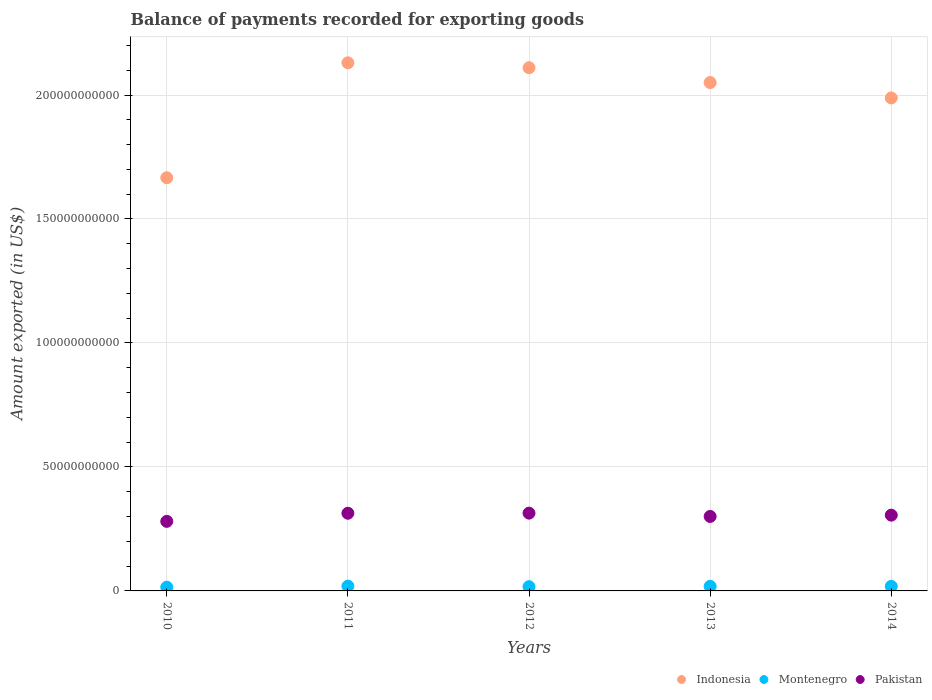What is the amount exported in Indonesia in 2011?
Your answer should be compact. 2.13e+11. Across all years, what is the maximum amount exported in Pakistan?
Your answer should be compact. 3.14e+1. Across all years, what is the minimum amount exported in Montenegro?
Ensure brevity in your answer.  1.50e+09. What is the total amount exported in Pakistan in the graph?
Keep it short and to the point. 1.51e+11. What is the difference between the amount exported in Indonesia in 2012 and that in 2013?
Offer a terse response. 5.97e+09. What is the difference between the amount exported in Indonesia in 2014 and the amount exported in Montenegro in 2012?
Your response must be concise. 1.97e+11. What is the average amount exported in Montenegro per year?
Provide a short and direct response. 1.77e+09. In the year 2013, what is the difference between the amount exported in Montenegro and amount exported in Indonesia?
Keep it short and to the point. -2.03e+11. What is the ratio of the amount exported in Indonesia in 2011 to that in 2013?
Make the answer very short. 1.04. Is the amount exported in Indonesia in 2010 less than that in 2013?
Ensure brevity in your answer.  Yes. What is the difference between the highest and the second highest amount exported in Pakistan?
Keep it short and to the point. 4.27e+07. What is the difference between the highest and the lowest amount exported in Pakistan?
Your answer should be very brief. 3.32e+09. Is it the case that in every year, the sum of the amount exported in Montenegro and amount exported in Pakistan  is greater than the amount exported in Indonesia?
Your answer should be very brief. No. Does the amount exported in Indonesia monotonically increase over the years?
Provide a succinct answer. No. How many dotlines are there?
Offer a terse response. 3. How many years are there in the graph?
Offer a terse response. 5. What is the difference between two consecutive major ticks on the Y-axis?
Give a very brief answer. 5.00e+1. Are the values on the major ticks of Y-axis written in scientific E-notation?
Offer a terse response. No. Does the graph contain any zero values?
Offer a terse response. No. Does the graph contain grids?
Offer a very short reply. Yes. How many legend labels are there?
Give a very brief answer. 3. How are the legend labels stacked?
Your response must be concise. Horizontal. What is the title of the graph?
Your answer should be very brief. Balance of payments recorded for exporting goods. Does "Somalia" appear as one of the legend labels in the graph?
Keep it short and to the point. No. What is the label or title of the Y-axis?
Offer a very short reply. Amount exported (in US$). What is the Amount exported (in US$) in Indonesia in 2010?
Keep it short and to the point. 1.67e+11. What is the Amount exported (in US$) of Montenegro in 2010?
Provide a short and direct response. 1.50e+09. What is the Amount exported (in US$) of Pakistan in 2010?
Your answer should be very brief. 2.81e+1. What is the Amount exported (in US$) in Indonesia in 2011?
Make the answer very short. 2.13e+11. What is the Amount exported (in US$) of Montenegro in 2011?
Offer a very short reply. 1.93e+09. What is the Amount exported (in US$) of Pakistan in 2011?
Your response must be concise. 3.13e+1. What is the Amount exported (in US$) of Indonesia in 2012?
Provide a short and direct response. 2.11e+11. What is the Amount exported (in US$) in Montenegro in 2012?
Keep it short and to the point. 1.71e+09. What is the Amount exported (in US$) of Pakistan in 2012?
Ensure brevity in your answer.  3.14e+1. What is the Amount exported (in US$) of Indonesia in 2013?
Offer a very short reply. 2.05e+11. What is the Amount exported (in US$) of Montenegro in 2013?
Offer a terse response. 1.84e+09. What is the Amount exported (in US$) of Pakistan in 2013?
Provide a short and direct response. 3.00e+1. What is the Amount exported (in US$) of Indonesia in 2014?
Ensure brevity in your answer.  1.99e+11. What is the Amount exported (in US$) of Montenegro in 2014?
Give a very brief answer. 1.84e+09. What is the Amount exported (in US$) in Pakistan in 2014?
Ensure brevity in your answer.  3.06e+1. Across all years, what is the maximum Amount exported (in US$) in Indonesia?
Make the answer very short. 2.13e+11. Across all years, what is the maximum Amount exported (in US$) of Montenegro?
Keep it short and to the point. 1.93e+09. Across all years, what is the maximum Amount exported (in US$) of Pakistan?
Your answer should be compact. 3.14e+1. Across all years, what is the minimum Amount exported (in US$) in Indonesia?
Your answer should be very brief. 1.67e+11. Across all years, what is the minimum Amount exported (in US$) in Montenegro?
Make the answer very short. 1.50e+09. Across all years, what is the minimum Amount exported (in US$) in Pakistan?
Your answer should be compact. 2.81e+1. What is the total Amount exported (in US$) in Indonesia in the graph?
Your answer should be very brief. 9.94e+11. What is the total Amount exported (in US$) in Montenegro in the graph?
Offer a terse response. 8.83e+09. What is the total Amount exported (in US$) in Pakistan in the graph?
Offer a terse response. 1.51e+11. What is the difference between the Amount exported (in US$) in Indonesia in 2010 and that in 2011?
Offer a terse response. -4.64e+1. What is the difference between the Amount exported (in US$) of Montenegro in 2010 and that in 2011?
Your answer should be very brief. -4.27e+08. What is the difference between the Amount exported (in US$) in Pakistan in 2010 and that in 2011?
Your answer should be very brief. -3.27e+09. What is the difference between the Amount exported (in US$) of Indonesia in 2010 and that in 2012?
Offer a very short reply. -4.44e+1. What is the difference between the Amount exported (in US$) of Montenegro in 2010 and that in 2012?
Your answer should be very brief. -2.07e+08. What is the difference between the Amount exported (in US$) of Pakistan in 2010 and that in 2012?
Offer a terse response. -3.32e+09. What is the difference between the Amount exported (in US$) in Indonesia in 2010 and that in 2013?
Your response must be concise. -3.84e+1. What is the difference between the Amount exported (in US$) of Montenegro in 2010 and that in 2013?
Offer a terse response. -3.40e+08. What is the difference between the Amount exported (in US$) in Pakistan in 2010 and that in 2013?
Make the answer very short. -1.98e+09. What is the difference between the Amount exported (in US$) in Indonesia in 2010 and that in 2014?
Your response must be concise. -3.22e+1. What is the difference between the Amount exported (in US$) in Montenegro in 2010 and that in 2014?
Give a very brief answer. -3.39e+08. What is the difference between the Amount exported (in US$) of Pakistan in 2010 and that in 2014?
Your answer should be compact. -2.50e+09. What is the difference between the Amount exported (in US$) in Indonesia in 2011 and that in 2012?
Ensure brevity in your answer.  1.99e+09. What is the difference between the Amount exported (in US$) in Montenegro in 2011 and that in 2012?
Provide a succinct answer. 2.20e+08. What is the difference between the Amount exported (in US$) of Pakistan in 2011 and that in 2012?
Ensure brevity in your answer.  -4.27e+07. What is the difference between the Amount exported (in US$) of Indonesia in 2011 and that in 2013?
Provide a short and direct response. 7.96e+09. What is the difference between the Amount exported (in US$) of Montenegro in 2011 and that in 2013?
Your answer should be very brief. 8.72e+07. What is the difference between the Amount exported (in US$) in Pakistan in 2011 and that in 2013?
Offer a terse response. 1.29e+09. What is the difference between the Amount exported (in US$) in Indonesia in 2011 and that in 2014?
Ensure brevity in your answer.  1.42e+1. What is the difference between the Amount exported (in US$) of Montenegro in 2011 and that in 2014?
Offer a very short reply. 8.82e+07. What is the difference between the Amount exported (in US$) in Pakistan in 2011 and that in 2014?
Your response must be concise. 7.67e+08. What is the difference between the Amount exported (in US$) in Indonesia in 2012 and that in 2013?
Make the answer very short. 5.97e+09. What is the difference between the Amount exported (in US$) in Montenegro in 2012 and that in 2013?
Your answer should be compact. -1.33e+08. What is the difference between the Amount exported (in US$) in Pakistan in 2012 and that in 2013?
Your response must be concise. 1.34e+09. What is the difference between the Amount exported (in US$) of Indonesia in 2012 and that in 2014?
Keep it short and to the point. 1.22e+1. What is the difference between the Amount exported (in US$) of Montenegro in 2012 and that in 2014?
Your response must be concise. -1.32e+08. What is the difference between the Amount exported (in US$) in Pakistan in 2012 and that in 2014?
Offer a very short reply. 8.10e+08. What is the difference between the Amount exported (in US$) in Indonesia in 2013 and that in 2014?
Offer a terse response. 6.21e+09. What is the difference between the Amount exported (in US$) of Montenegro in 2013 and that in 2014?
Make the answer very short. 9.82e+05. What is the difference between the Amount exported (in US$) in Pakistan in 2013 and that in 2014?
Provide a succinct answer. -5.26e+08. What is the difference between the Amount exported (in US$) in Indonesia in 2010 and the Amount exported (in US$) in Montenegro in 2011?
Ensure brevity in your answer.  1.65e+11. What is the difference between the Amount exported (in US$) of Indonesia in 2010 and the Amount exported (in US$) of Pakistan in 2011?
Ensure brevity in your answer.  1.35e+11. What is the difference between the Amount exported (in US$) of Montenegro in 2010 and the Amount exported (in US$) of Pakistan in 2011?
Your answer should be very brief. -2.98e+1. What is the difference between the Amount exported (in US$) of Indonesia in 2010 and the Amount exported (in US$) of Montenegro in 2012?
Provide a short and direct response. 1.65e+11. What is the difference between the Amount exported (in US$) of Indonesia in 2010 and the Amount exported (in US$) of Pakistan in 2012?
Offer a terse response. 1.35e+11. What is the difference between the Amount exported (in US$) of Montenegro in 2010 and the Amount exported (in US$) of Pakistan in 2012?
Provide a succinct answer. -2.99e+1. What is the difference between the Amount exported (in US$) of Indonesia in 2010 and the Amount exported (in US$) of Montenegro in 2013?
Keep it short and to the point. 1.65e+11. What is the difference between the Amount exported (in US$) of Indonesia in 2010 and the Amount exported (in US$) of Pakistan in 2013?
Give a very brief answer. 1.37e+11. What is the difference between the Amount exported (in US$) of Montenegro in 2010 and the Amount exported (in US$) of Pakistan in 2013?
Give a very brief answer. -2.85e+1. What is the difference between the Amount exported (in US$) of Indonesia in 2010 and the Amount exported (in US$) of Montenegro in 2014?
Your answer should be compact. 1.65e+11. What is the difference between the Amount exported (in US$) of Indonesia in 2010 and the Amount exported (in US$) of Pakistan in 2014?
Provide a short and direct response. 1.36e+11. What is the difference between the Amount exported (in US$) of Montenegro in 2010 and the Amount exported (in US$) of Pakistan in 2014?
Offer a terse response. -2.91e+1. What is the difference between the Amount exported (in US$) in Indonesia in 2011 and the Amount exported (in US$) in Montenegro in 2012?
Provide a short and direct response. 2.11e+11. What is the difference between the Amount exported (in US$) of Indonesia in 2011 and the Amount exported (in US$) of Pakistan in 2012?
Give a very brief answer. 1.82e+11. What is the difference between the Amount exported (in US$) in Montenegro in 2011 and the Amount exported (in US$) in Pakistan in 2012?
Your response must be concise. -2.94e+1. What is the difference between the Amount exported (in US$) in Indonesia in 2011 and the Amount exported (in US$) in Montenegro in 2013?
Give a very brief answer. 2.11e+11. What is the difference between the Amount exported (in US$) in Indonesia in 2011 and the Amount exported (in US$) in Pakistan in 2013?
Offer a very short reply. 1.83e+11. What is the difference between the Amount exported (in US$) in Montenegro in 2011 and the Amount exported (in US$) in Pakistan in 2013?
Your answer should be compact. -2.81e+1. What is the difference between the Amount exported (in US$) in Indonesia in 2011 and the Amount exported (in US$) in Montenegro in 2014?
Offer a very short reply. 2.11e+11. What is the difference between the Amount exported (in US$) of Indonesia in 2011 and the Amount exported (in US$) of Pakistan in 2014?
Keep it short and to the point. 1.82e+11. What is the difference between the Amount exported (in US$) in Montenegro in 2011 and the Amount exported (in US$) in Pakistan in 2014?
Ensure brevity in your answer.  -2.86e+1. What is the difference between the Amount exported (in US$) of Indonesia in 2012 and the Amount exported (in US$) of Montenegro in 2013?
Provide a succinct answer. 2.09e+11. What is the difference between the Amount exported (in US$) of Indonesia in 2012 and the Amount exported (in US$) of Pakistan in 2013?
Make the answer very short. 1.81e+11. What is the difference between the Amount exported (in US$) of Montenegro in 2012 and the Amount exported (in US$) of Pakistan in 2013?
Provide a short and direct response. -2.83e+1. What is the difference between the Amount exported (in US$) in Indonesia in 2012 and the Amount exported (in US$) in Montenegro in 2014?
Provide a short and direct response. 2.09e+11. What is the difference between the Amount exported (in US$) in Indonesia in 2012 and the Amount exported (in US$) in Pakistan in 2014?
Your answer should be very brief. 1.80e+11. What is the difference between the Amount exported (in US$) of Montenegro in 2012 and the Amount exported (in US$) of Pakistan in 2014?
Provide a succinct answer. -2.89e+1. What is the difference between the Amount exported (in US$) of Indonesia in 2013 and the Amount exported (in US$) of Montenegro in 2014?
Provide a short and direct response. 2.03e+11. What is the difference between the Amount exported (in US$) in Indonesia in 2013 and the Amount exported (in US$) in Pakistan in 2014?
Keep it short and to the point. 1.74e+11. What is the difference between the Amount exported (in US$) in Montenegro in 2013 and the Amount exported (in US$) in Pakistan in 2014?
Your answer should be compact. -2.87e+1. What is the average Amount exported (in US$) in Indonesia per year?
Make the answer very short. 1.99e+11. What is the average Amount exported (in US$) of Montenegro per year?
Provide a succinct answer. 1.77e+09. What is the average Amount exported (in US$) in Pakistan per year?
Your answer should be very brief. 3.03e+1. In the year 2010, what is the difference between the Amount exported (in US$) of Indonesia and Amount exported (in US$) of Montenegro?
Keep it short and to the point. 1.65e+11. In the year 2010, what is the difference between the Amount exported (in US$) in Indonesia and Amount exported (in US$) in Pakistan?
Make the answer very short. 1.39e+11. In the year 2010, what is the difference between the Amount exported (in US$) in Montenegro and Amount exported (in US$) in Pakistan?
Keep it short and to the point. -2.66e+1. In the year 2011, what is the difference between the Amount exported (in US$) in Indonesia and Amount exported (in US$) in Montenegro?
Keep it short and to the point. 2.11e+11. In the year 2011, what is the difference between the Amount exported (in US$) of Indonesia and Amount exported (in US$) of Pakistan?
Offer a very short reply. 1.82e+11. In the year 2011, what is the difference between the Amount exported (in US$) in Montenegro and Amount exported (in US$) in Pakistan?
Your answer should be compact. -2.94e+1. In the year 2012, what is the difference between the Amount exported (in US$) of Indonesia and Amount exported (in US$) of Montenegro?
Offer a very short reply. 2.09e+11. In the year 2012, what is the difference between the Amount exported (in US$) of Indonesia and Amount exported (in US$) of Pakistan?
Your answer should be very brief. 1.80e+11. In the year 2012, what is the difference between the Amount exported (in US$) in Montenegro and Amount exported (in US$) in Pakistan?
Provide a short and direct response. -2.97e+1. In the year 2013, what is the difference between the Amount exported (in US$) in Indonesia and Amount exported (in US$) in Montenegro?
Give a very brief answer. 2.03e+11. In the year 2013, what is the difference between the Amount exported (in US$) in Indonesia and Amount exported (in US$) in Pakistan?
Give a very brief answer. 1.75e+11. In the year 2013, what is the difference between the Amount exported (in US$) in Montenegro and Amount exported (in US$) in Pakistan?
Offer a very short reply. -2.82e+1. In the year 2014, what is the difference between the Amount exported (in US$) of Indonesia and Amount exported (in US$) of Montenegro?
Offer a terse response. 1.97e+11. In the year 2014, what is the difference between the Amount exported (in US$) of Indonesia and Amount exported (in US$) of Pakistan?
Provide a succinct answer. 1.68e+11. In the year 2014, what is the difference between the Amount exported (in US$) of Montenegro and Amount exported (in US$) of Pakistan?
Provide a short and direct response. -2.87e+1. What is the ratio of the Amount exported (in US$) of Indonesia in 2010 to that in 2011?
Keep it short and to the point. 0.78. What is the ratio of the Amount exported (in US$) in Montenegro in 2010 to that in 2011?
Keep it short and to the point. 0.78. What is the ratio of the Amount exported (in US$) of Pakistan in 2010 to that in 2011?
Your answer should be very brief. 0.9. What is the ratio of the Amount exported (in US$) in Indonesia in 2010 to that in 2012?
Your answer should be compact. 0.79. What is the ratio of the Amount exported (in US$) in Montenegro in 2010 to that in 2012?
Ensure brevity in your answer.  0.88. What is the ratio of the Amount exported (in US$) of Pakistan in 2010 to that in 2012?
Keep it short and to the point. 0.89. What is the ratio of the Amount exported (in US$) in Indonesia in 2010 to that in 2013?
Ensure brevity in your answer.  0.81. What is the ratio of the Amount exported (in US$) in Montenegro in 2010 to that in 2013?
Your answer should be very brief. 0.82. What is the ratio of the Amount exported (in US$) in Pakistan in 2010 to that in 2013?
Give a very brief answer. 0.93. What is the ratio of the Amount exported (in US$) in Indonesia in 2010 to that in 2014?
Your answer should be compact. 0.84. What is the ratio of the Amount exported (in US$) of Montenegro in 2010 to that in 2014?
Your answer should be very brief. 0.82. What is the ratio of the Amount exported (in US$) in Pakistan in 2010 to that in 2014?
Provide a short and direct response. 0.92. What is the ratio of the Amount exported (in US$) in Indonesia in 2011 to that in 2012?
Your answer should be very brief. 1.01. What is the ratio of the Amount exported (in US$) in Montenegro in 2011 to that in 2012?
Keep it short and to the point. 1.13. What is the ratio of the Amount exported (in US$) in Pakistan in 2011 to that in 2012?
Keep it short and to the point. 1. What is the ratio of the Amount exported (in US$) of Indonesia in 2011 to that in 2013?
Make the answer very short. 1.04. What is the ratio of the Amount exported (in US$) in Montenegro in 2011 to that in 2013?
Your answer should be compact. 1.05. What is the ratio of the Amount exported (in US$) in Pakistan in 2011 to that in 2013?
Give a very brief answer. 1.04. What is the ratio of the Amount exported (in US$) in Indonesia in 2011 to that in 2014?
Your answer should be compact. 1.07. What is the ratio of the Amount exported (in US$) of Montenegro in 2011 to that in 2014?
Your answer should be very brief. 1.05. What is the ratio of the Amount exported (in US$) of Pakistan in 2011 to that in 2014?
Give a very brief answer. 1.03. What is the ratio of the Amount exported (in US$) of Indonesia in 2012 to that in 2013?
Provide a short and direct response. 1.03. What is the ratio of the Amount exported (in US$) of Montenegro in 2012 to that in 2013?
Your answer should be compact. 0.93. What is the ratio of the Amount exported (in US$) in Pakistan in 2012 to that in 2013?
Keep it short and to the point. 1.04. What is the ratio of the Amount exported (in US$) in Indonesia in 2012 to that in 2014?
Give a very brief answer. 1.06. What is the ratio of the Amount exported (in US$) in Montenegro in 2012 to that in 2014?
Keep it short and to the point. 0.93. What is the ratio of the Amount exported (in US$) of Pakistan in 2012 to that in 2014?
Your answer should be compact. 1.03. What is the ratio of the Amount exported (in US$) in Indonesia in 2013 to that in 2014?
Your answer should be compact. 1.03. What is the ratio of the Amount exported (in US$) of Montenegro in 2013 to that in 2014?
Offer a very short reply. 1. What is the ratio of the Amount exported (in US$) of Pakistan in 2013 to that in 2014?
Offer a terse response. 0.98. What is the difference between the highest and the second highest Amount exported (in US$) of Indonesia?
Your response must be concise. 1.99e+09. What is the difference between the highest and the second highest Amount exported (in US$) in Montenegro?
Your answer should be compact. 8.72e+07. What is the difference between the highest and the second highest Amount exported (in US$) in Pakistan?
Your answer should be compact. 4.27e+07. What is the difference between the highest and the lowest Amount exported (in US$) in Indonesia?
Your answer should be compact. 4.64e+1. What is the difference between the highest and the lowest Amount exported (in US$) of Montenegro?
Ensure brevity in your answer.  4.27e+08. What is the difference between the highest and the lowest Amount exported (in US$) in Pakistan?
Provide a succinct answer. 3.32e+09. 